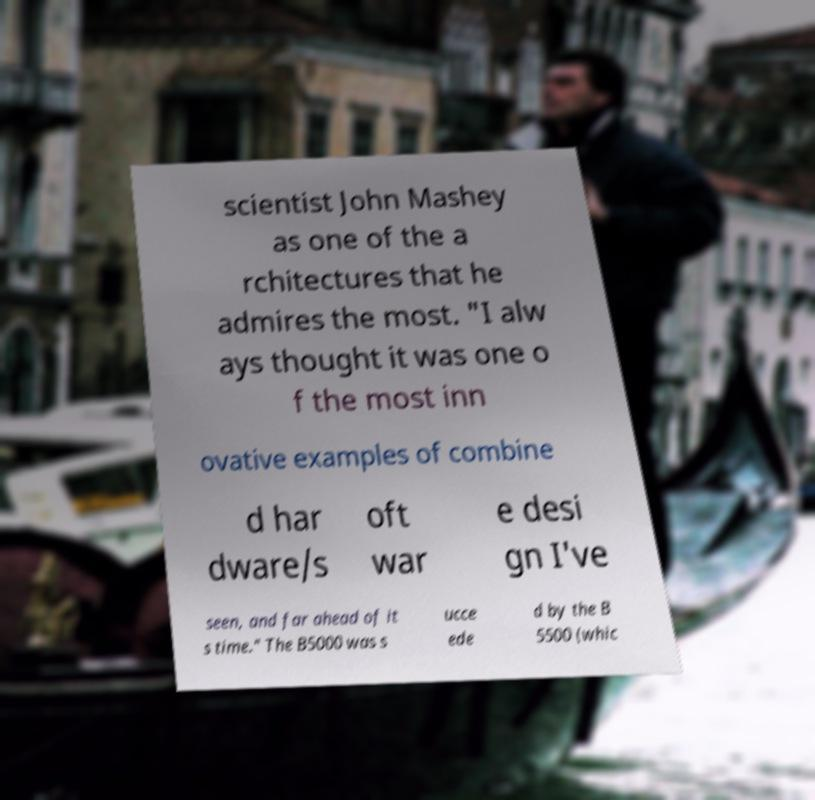Please read and relay the text visible in this image. What does it say? scientist John Mashey as one of the a rchitectures that he admires the most. "I alw ays thought it was one o f the most inn ovative examples of combine d har dware/s oft war e desi gn I've seen, and far ahead of it s time." The B5000 was s ucce ede d by the B 5500 (whic 